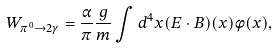<formula> <loc_0><loc_0><loc_500><loc_500>W _ { \pi ^ { 0 } \to 2 \gamma } = \frac { \alpha } { \pi } \frac { g } { m } \int d ^ { 4 } x ( E \cdot B ) ( x ) \phi ( x ) ,</formula> 